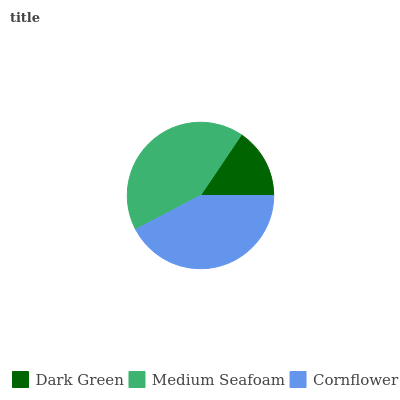Is Dark Green the minimum?
Answer yes or no. Yes. Is Cornflower the maximum?
Answer yes or no. Yes. Is Medium Seafoam the minimum?
Answer yes or no. No. Is Medium Seafoam the maximum?
Answer yes or no. No. Is Medium Seafoam greater than Dark Green?
Answer yes or no. Yes. Is Dark Green less than Medium Seafoam?
Answer yes or no. Yes. Is Dark Green greater than Medium Seafoam?
Answer yes or no. No. Is Medium Seafoam less than Dark Green?
Answer yes or no. No. Is Medium Seafoam the high median?
Answer yes or no. Yes. Is Medium Seafoam the low median?
Answer yes or no. Yes. Is Dark Green the high median?
Answer yes or no. No. Is Dark Green the low median?
Answer yes or no. No. 